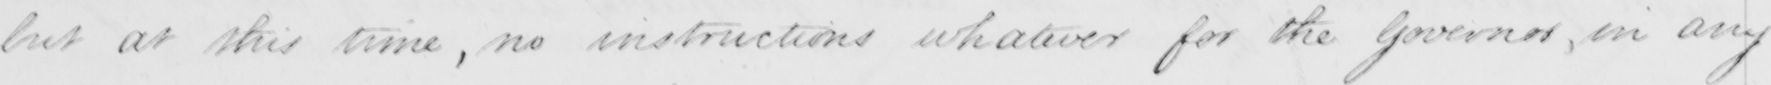Transcribe the text shown in this historical manuscript line. but at this time , no instructions whatever for the Governor , in any 